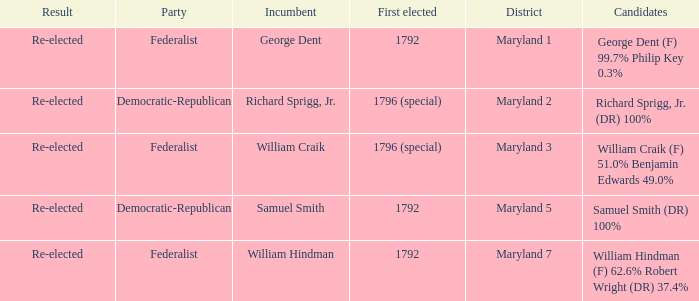What is the district for the party federalist and the candidates are william craik (f) 51.0% benjamin edwards 49.0%? Maryland 3. I'm looking to parse the entire table for insights. Could you assist me with that? {'header': ['Result', 'Party', 'Incumbent', 'First elected', 'District', 'Candidates'], 'rows': [['Re-elected', 'Federalist', 'George Dent', '1792', 'Maryland 1', 'George Dent (F) 99.7% Philip Key 0.3%'], ['Re-elected', 'Democratic-Republican', 'Richard Sprigg, Jr.', '1796 (special)', 'Maryland 2', 'Richard Sprigg, Jr. (DR) 100%'], ['Re-elected', 'Federalist', 'William Craik', '1796 (special)', 'Maryland 3', 'William Craik (F) 51.0% Benjamin Edwards 49.0%'], ['Re-elected', 'Democratic-Republican', 'Samuel Smith', '1792', 'Maryland 5', 'Samuel Smith (DR) 100%'], ['Re-elected', 'Federalist', 'William Hindman', '1792', 'Maryland 7', 'William Hindman (F) 62.6% Robert Wright (DR) 37.4%']]} 